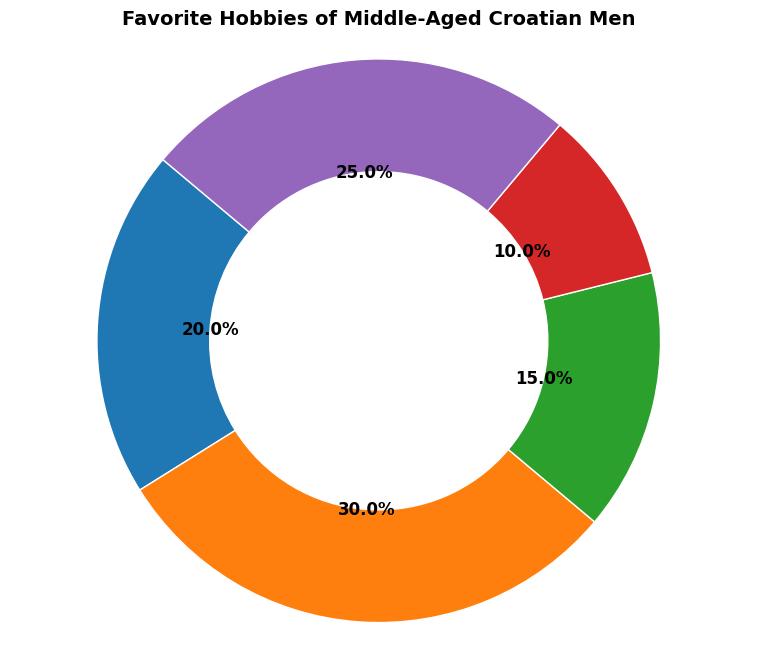What percentage of middle-aged Croatian men prefer Football over Tennis? Football is represented by a larger wedge compared to Tennis. According to the figure, Football has a popularity of 30%, while Tennis has 20%. To find the difference in preference percentages, we calculate 30% (Football) - 20% (Tennis) = 10%.
Answer: 10% Which hobby is the least popular among middle-aged Croatian men, and what is its percentage? Based on the sizes of the wedges, Hiking is the smallest wedge among the given hobbies in the ring chart. The chart shows that Hiking has a percentage of 10%.
Answer: Hiking, 10% Combine the popularity percentages of Tennis, Fishing, and Others. What is the total? Refer to the figure to identify the percentages of Tennis (20%), Fishing (15%), and Others (25%). Adding these together gives a total percentage: 20% + 15% + 25% = 60%.
Answer: 60% How much more popular is Football compared to Hiking? By referring to the chart, Football has a popularity of 30% while Hiking has 10%. Subtract Hiking's percentage from Football's: 30% (Football) - 10% (Hiking) = 20%.
Answer: 20% If you combine the popularity of Fishing and Hiking, how does it compare to the popularity of Football? Is it greater, less or equal? From the figure, Fishing has a popularity of 15% and Hiking has 10%. Their combined percentage is 15% + 10% = 25%. Football alone has a 30% popularity. Hence, the combined popularity of Fishing and Hiking (25%) is less than Football's (30%).
Answer: Less Which two hobbies together make up exactly half (50%) of the total preferences? According to the chart, combining the preferences of Football (30%) and Others (25%) results in 30% + 25% = 55%, which exceeds 50%. However, combining Tennis (20%) and Others (25%) results in 20% + 25% = 45%, which does not reach 50%. The correct pair is Football (30%) and Fishing (15%) yielding 30% + 15% = 45%, which still isn't 50%. On examining Tennis (20%) and Fishing (15%) yielding 35% which falls short. Thus, there is no pair that exactly makes up half of the total preferences.
Answer: None Which hobby has a similar size to Tennis, being closest in popularity but not the same? Inspecting the sizes in the ring chart, Tennis accounts for 20%, and the closest one in size would be Others which has 25%. Fishing, at 15%, is less close in comparison.
Answer: Others 